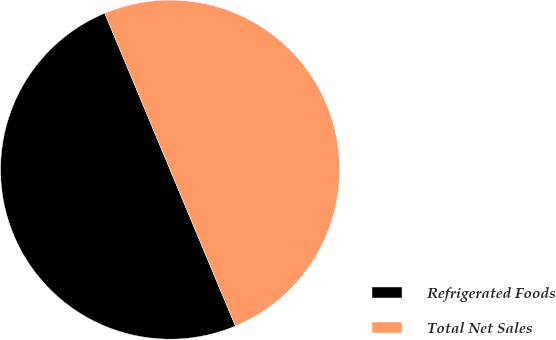<chart> <loc_0><loc_0><loc_500><loc_500><pie_chart><fcel>Refrigerated Foods<fcel>Total Net Sales<nl><fcel>50.0%<fcel>50.0%<nl></chart> 